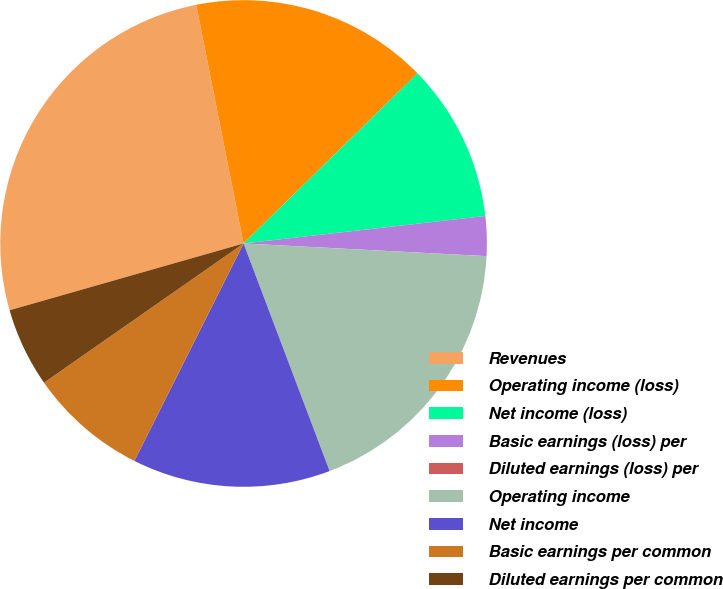Convert chart to OTSL. <chart><loc_0><loc_0><loc_500><loc_500><pie_chart><fcel>Revenues<fcel>Operating income (loss)<fcel>Net income (loss)<fcel>Basic earnings (loss) per<fcel>Diluted earnings (loss) per<fcel>Operating income<fcel>Net income<fcel>Basic earnings per common<fcel>Diluted earnings per common<nl><fcel>26.31%<fcel>15.79%<fcel>10.53%<fcel>2.63%<fcel>0.0%<fcel>18.42%<fcel>13.16%<fcel>7.9%<fcel>5.27%<nl></chart> 